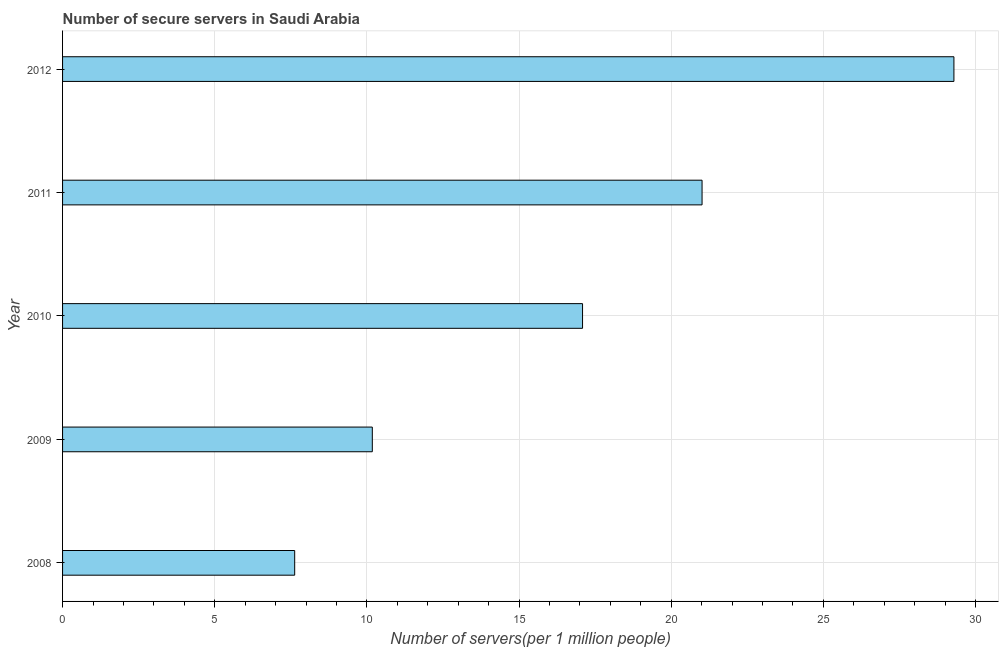Does the graph contain any zero values?
Keep it short and to the point. No. Does the graph contain grids?
Your answer should be compact. Yes. What is the title of the graph?
Your response must be concise. Number of secure servers in Saudi Arabia. What is the label or title of the X-axis?
Provide a short and direct response. Number of servers(per 1 million people). What is the number of secure internet servers in 2011?
Offer a very short reply. 21.02. Across all years, what is the maximum number of secure internet servers?
Your response must be concise. 29.29. Across all years, what is the minimum number of secure internet servers?
Provide a succinct answer. 7.63. In which year was the number of secure internet servers maximum?
Your answer should be very brief. 2012. What is the sum of the number of secure internet servers?
Make the answer very short. 85.2. What is the difference between the number of secure internet servers in 2010 and 2012?
Ensure brevity in your answer.  -12.21. What is the average number of secure internet servers per year?
Your answer should be very brief. 17.04. What is the median number of secure internet servers?
Your answer should be compact. 17.09. Do a majority of the years between 2008 and 2009 (inclusive) have number of secure internet servers greater than 23 ?
Ensure brevity in your answer.  No. What is the ratio of the number of secure internet servers in 2008 to that in 2010?
Give a very brief answer. 0.45. Is the number of secure internet servers in 2011 less than that in 2012?
Make the answer very short. Yes. Is the difference between the number of secure internet servers in 2008 and 2009 greater than the difference between any two years?
Make the answer very short. No. What is the difference between the highest and the second highest number of secure internet servers?
Your answer should be very brief. 8.28. Is the sum of the number of secure internet servers in 2010 and 2012 greater than the maximum number of secure internet servers across all years?
Provide a short and direct response. Yes. What is the difference between the highest and the lowest number of secure internet servers?
Your answer should be very brief. 21.66. In how many years, is the number of secure internet servers greater than the average number of secure internet servers taken over all years?
Keep it short and to the point. 3. How many bars are there?
Provide a succinct answer. 5. Are all the bars in the graph horizontal?
Give a very brief answer. Yes. How many years are there in the graph?
Make the answer very short. 5. What is the difference between two consecutive major ticks on the X-axis?
Provide a short and direct response. 5. What is the Number of servers(per 1 million people) of 2008?
Ensure brevity in your answer.  7.63. What is the Number of servers(per 1 million people) in 2009?
Ensure brevity in your answer.  10.18. What is the Number of servers(per 1 million people) of 2010?
Give a very brief answer. 17.09. What is the Number of servers(per 1 million people) in 2011?
Give a very brief answer. 21.02. What is the Number of servers(per 1 million people) in 2012?
Your answer should be compact. 29.29. What is the difference between the Number of servers(per 1 million people) in 2008 and 2009?
Give a very brief answer. -2.55. What is the difference between the Number of servers(per 1 million people) in 2008 and 2010?
Make the answer very short. -9.46. What is the difference between the Number of servers(per 1 million people) in 2008 and 2011?
Your response must be concise. -13.39. What is the difference between the Number of servers(per 1 million people) in 2008 and 2012?
Give a very brief answer. -21.66. What is the difference between the Number of servers(per 1 million people) in 2009 and 2010?
Ensure brevity in your answer.  -6.91. What is the difference between the Number of servers(per 1 million people) in 2009 and 2011?
Offer a terse response. -10.84. What is the difference between the Number of servers(per 1 million people) in 2009 and 2012?
Keep it short and to the point. -19.11. What is the difference between the Number of servers(per 1 million people) in 2010 and 2011?
Your answer should be compact. -3.93. What is the difference between the Number of servers(per 1 million people) in 2010 and 2012?
Ensure brevity in your answer.  -12.2. What is the difference between the Number of servers(per 1 million people) in 2011 and 2012?
Offer a terse response. -8.28. What is the ratio of the Number of servers(per 1 million people) in 2008 to that in 2009?
Keep it short and to the point. 0.75. What is the ratio of the Number of servers(per 1 million people) in 2008 to that in 2010?
Make the answer very short. 0.45. What is the ratio of the Number of servers(per 1 million people) in 2008 to that in 2011?
Ensure brevity in your answer.  0.36. What is the ratio of the Number of servers(per 1 million people) in 2008 to that in 2012?
Your answer should be compact. 0.26. What is the ratio of the Number of servers(per 1 million people) in 2009 to that in 2010?
Your answer should be very brief. 0.6. What is the ratio of the Number of servers(per 1 million people) in 2009 to that in 2011?
Keep it short and to the point. 0.48. What is the ratio of the Number of servers(per 1 million people) in 2009 to that in 2012?
Provide a succinct answer. 0.35. What is the ratio of the Number of servers(per 1 million people) in 2010 to that in 2011?
Offer a terse response. 0.81. What is the ratio of the Number of servers(per 1 million people) in 2010 to that in 2012?
Provide a succinct answer. 0.58. What is the ratio of the Number of servers(per 1 million people) in 2011 to that in 2012?
Your answer should be compact. 0.72. 